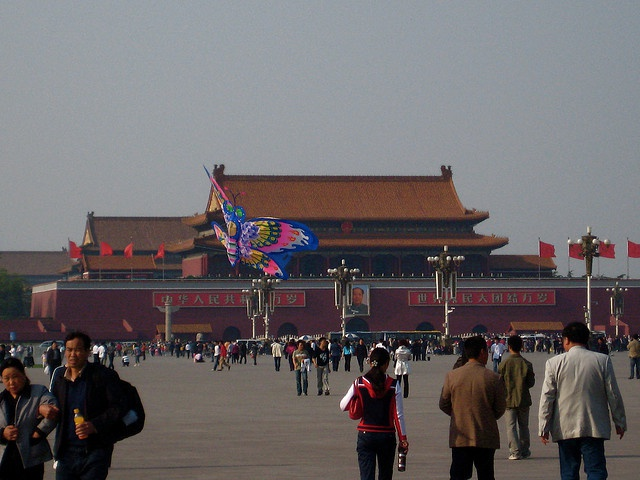Describe the objects in this image and their specific colors. I can see people in darkgray, black, gray, and maroon tones, people in darkgray, black, and gray tones, people in darkgray, black, maroon, gray, and brown tones, people in darkgray, black, maroon, and gray tones, and kite in darkgray, navy, black, and gray tones in this image. 